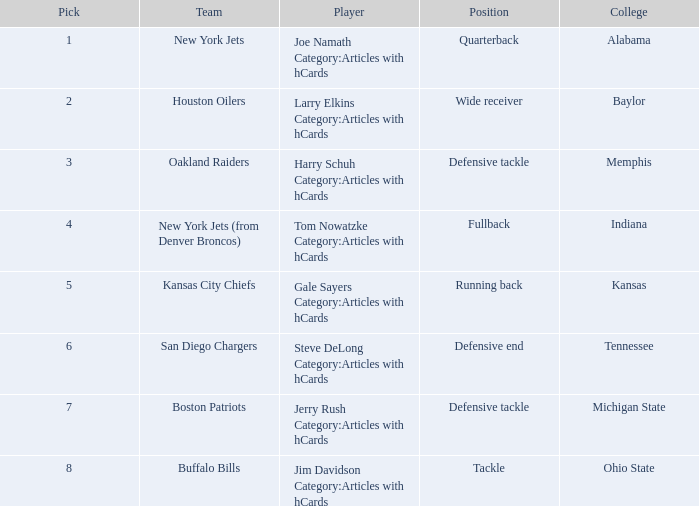What group has a spot of running back and chosen after 2? Kansas City Chiefs. 